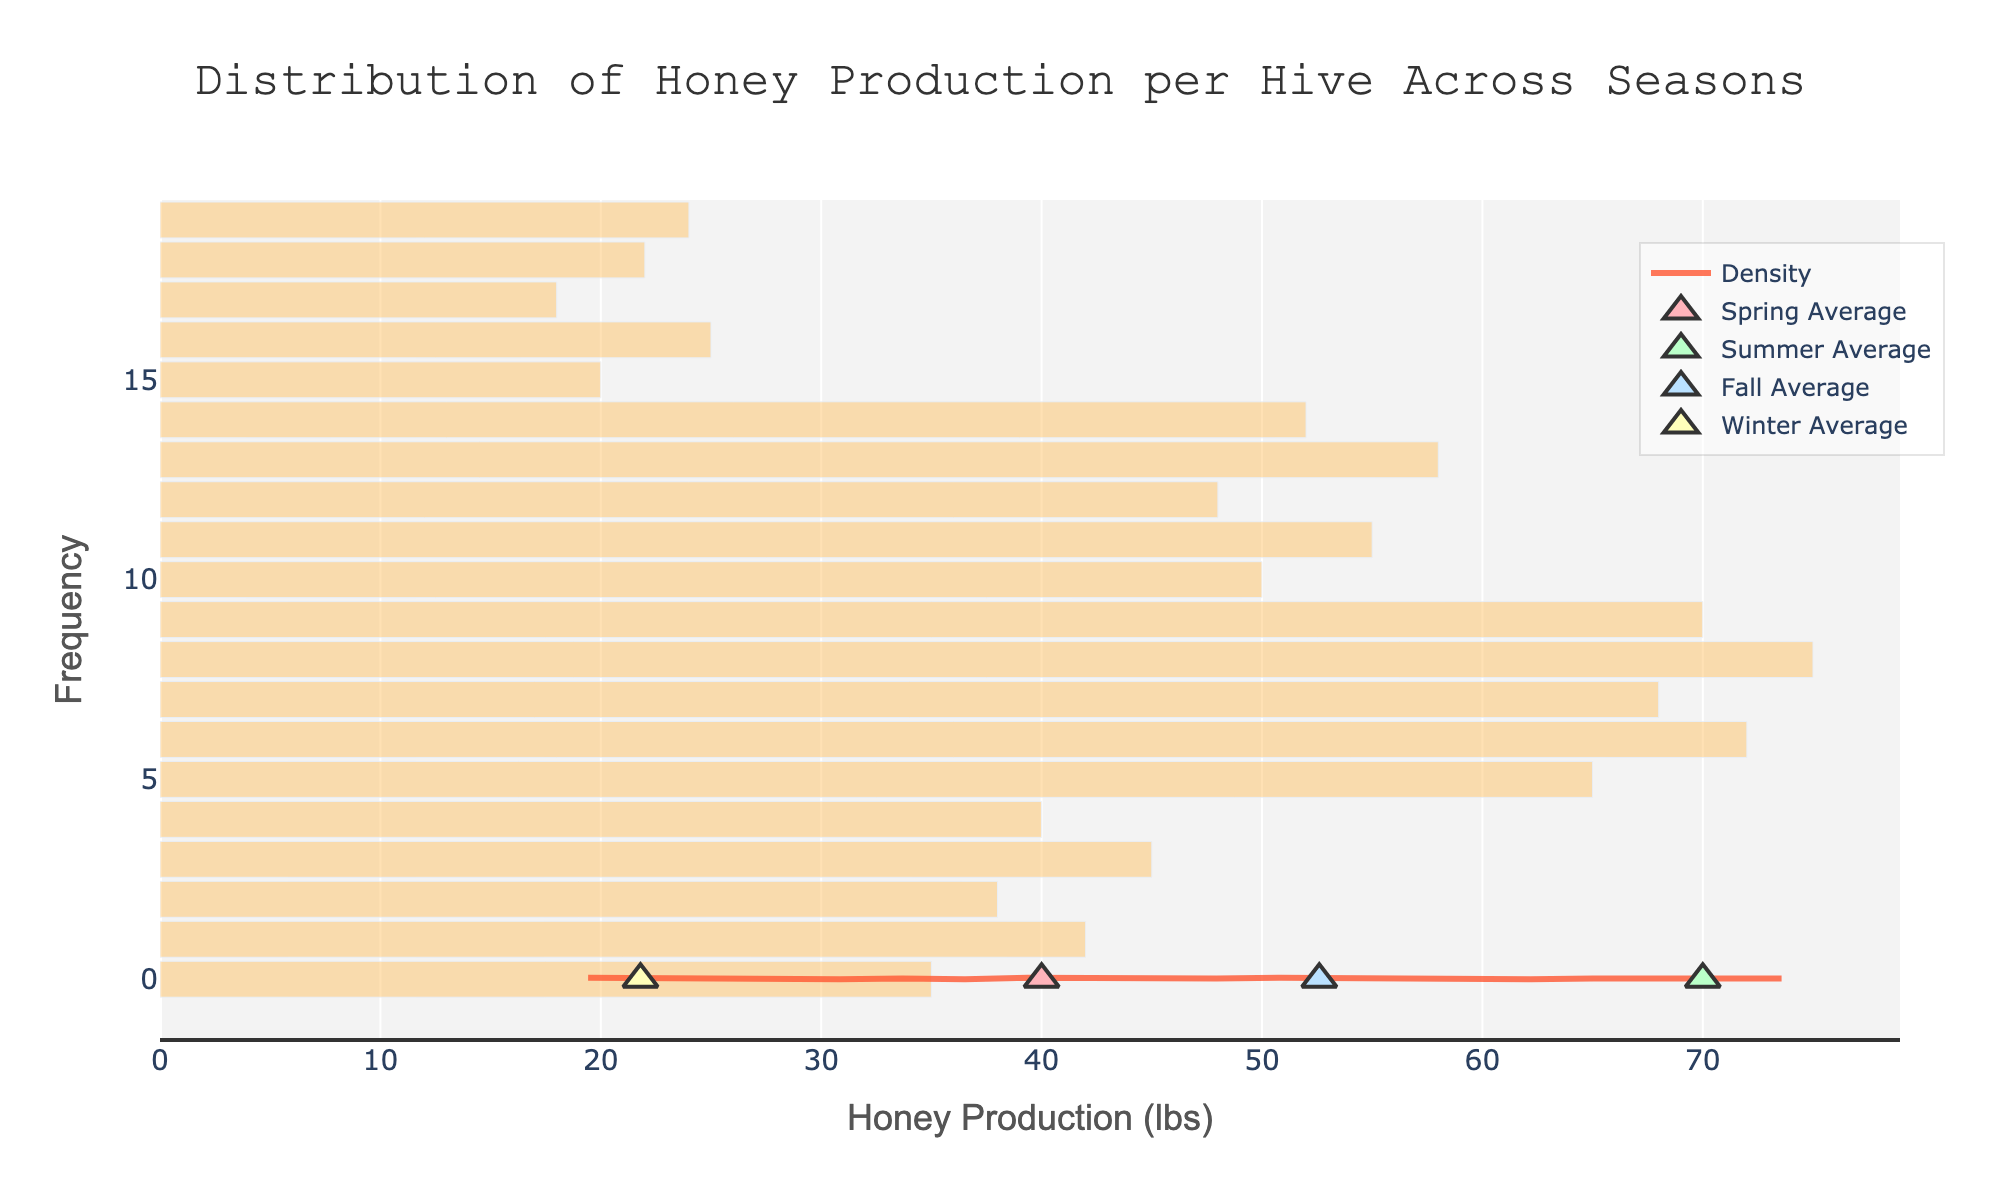What is the title of the figure? The title is clearly mentioned at the top of the figure.
Answer: Distribution of Honey Production per Hive Across Seasons What does the x-axis represent? The label on the x-axis shows what is being measured horizontally across the figure.
Answer: Honey Production (lbs) Which season has the highest average honey production? By looking at the markers representing the seasonal averages, determine which is positioned furthest to the right on the x-axis.
Answer: Summer How does the frequency of honey production in winter compare to summer? Observe the histograms' height for winter and summer. Winter's bars are shorter, indicating lower production frequency, while summer's bars are taller, showing higher frequency.
Answer: Lower in winter, higher in summer What is the range of honey production values across all seasons? Identify the minimum and maximum values on the x-axis covered by the histogram bars.
Answer: 18 to 75 lbs Which season has the lowest honey production range? Look at the spread of the histogram bars for each season. Winter has a smaller spread, indicating a narrower range.
Answer: Winter What is the approximate peak density value on the KDE curve? Find the highest point on the KDE curve and read the corresponding y-axis value.
Answer: Approximately 0.030 Are there any gaps in honey production values? Observe the histogram to see if there are intervals without any bars.
Answer: No noticeable gaps What do the different colors of markers represent? The legend or markers' hover information indicates that different colors represent different seasons.
Answer: Different seasons Which season's honey production has the widest distribution? Identify which season's histogram bars are spread out the most. Summer appears to have the widest distribution.
Answer: Summer 